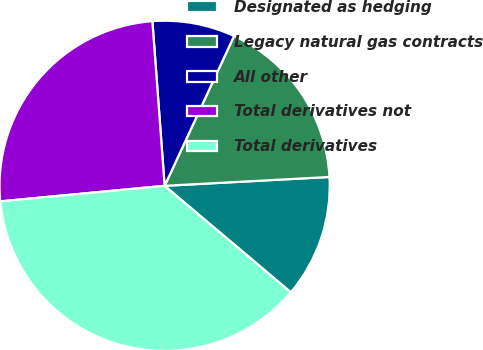Convert chart. <chart><loc_0><loc_0><loc_500><loc_500><pie_chart><fcel>Designated as hedging<fcel>Legacy natural gas contracts<fcel>All other<fcel>Total derivatives not<fcel>Total derivatives<nl><fcel>12.01%<fcel>17.24%<fcel>8.09%<fcel>25.32%<fcel>37.34%<nl></chart> 